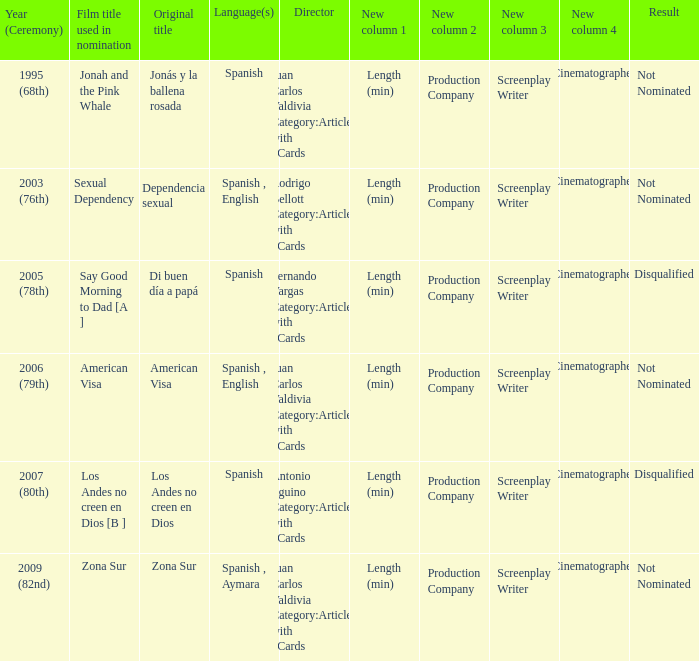In which year was zona sur nominated? 2009 (82nd). 